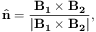<formula> <loc_0><loc_0><loc_500><loc_500>\hat { n } = \frac { B _ { 1 } \times B _ { 2 } } { | B _ { 1 } \times B _ { 2 } | } ,</formula> 